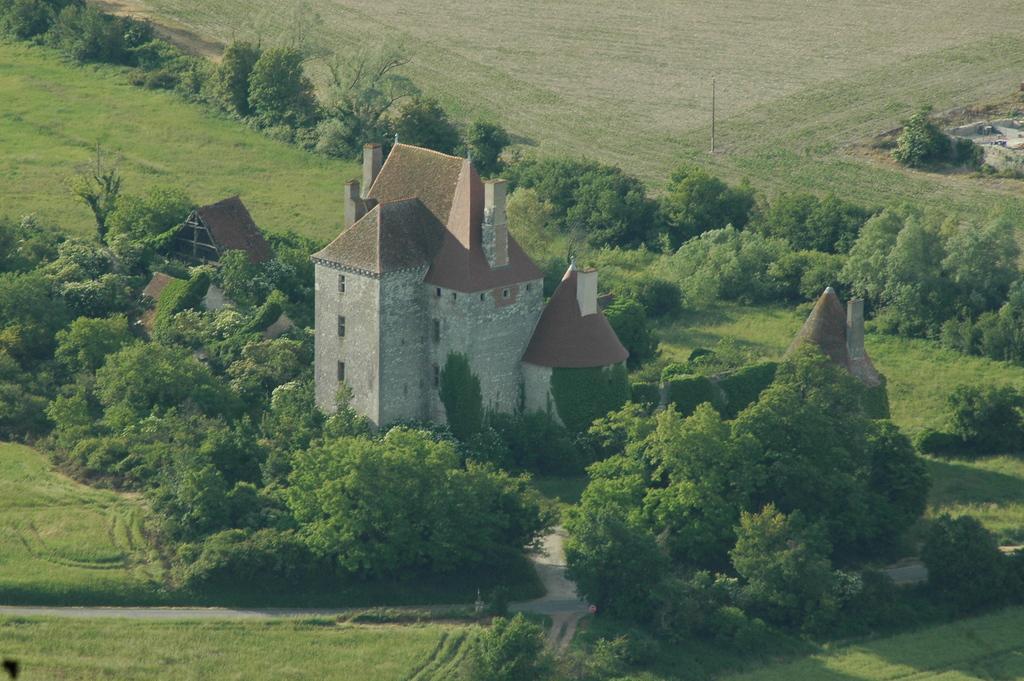Please provide a concise description of this image. In this image I can see houses, trees, grass and a pole. This image is taken may be during a day. 